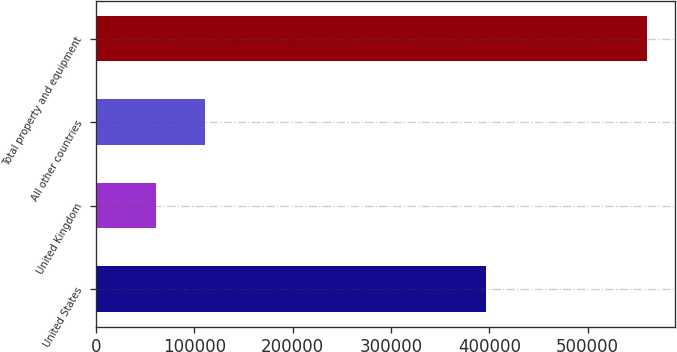<chart> <loc_0><loc_0><loc_500><loc_500><bar_chart><fcel>United States<fcel>United Kingdom<fcel>All other countries<fcel>Total property and equipment<nl><fcel>396608<fcel>61327<fcel>111270<fcel>560756<nl></chart> 